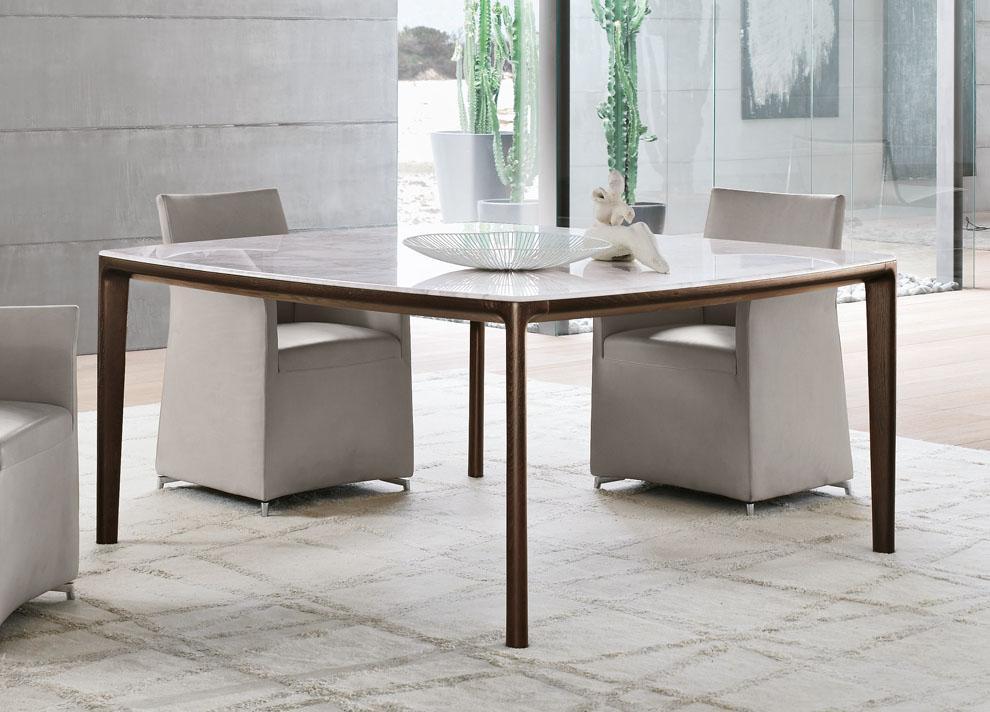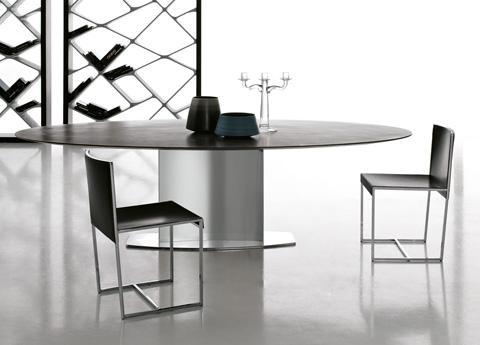The first image is the image on the left, the second image is the image on the right. Analyze the images presented: Is the assertion "A table in one image is round with two chairs." valid? Answer yes or no. Yes. The first image is the image on the left, the second image is the image on the right. Considering the images on both sides, is "One of the tables is round." valid? Answer yes or no. Yes. 